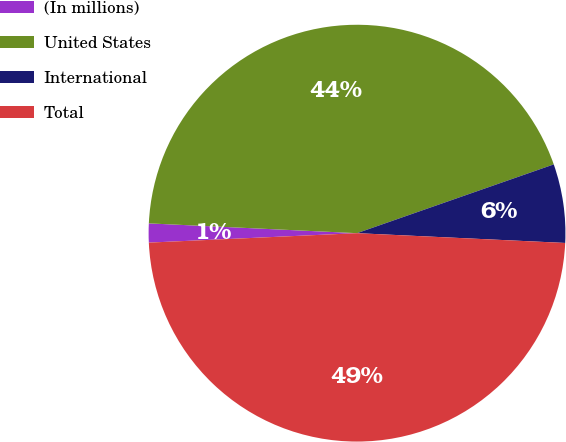Convert chart. <chart><loc_0><loc_0><loc_500><loc_500><pie_chart><fcel>(In millions)<fcel>United States<fcel>International<fcel>Total<nl><fcel>1.47%<fcel>43.9%<fcel>6.1%<fcel>48.53%<nl></chart> 